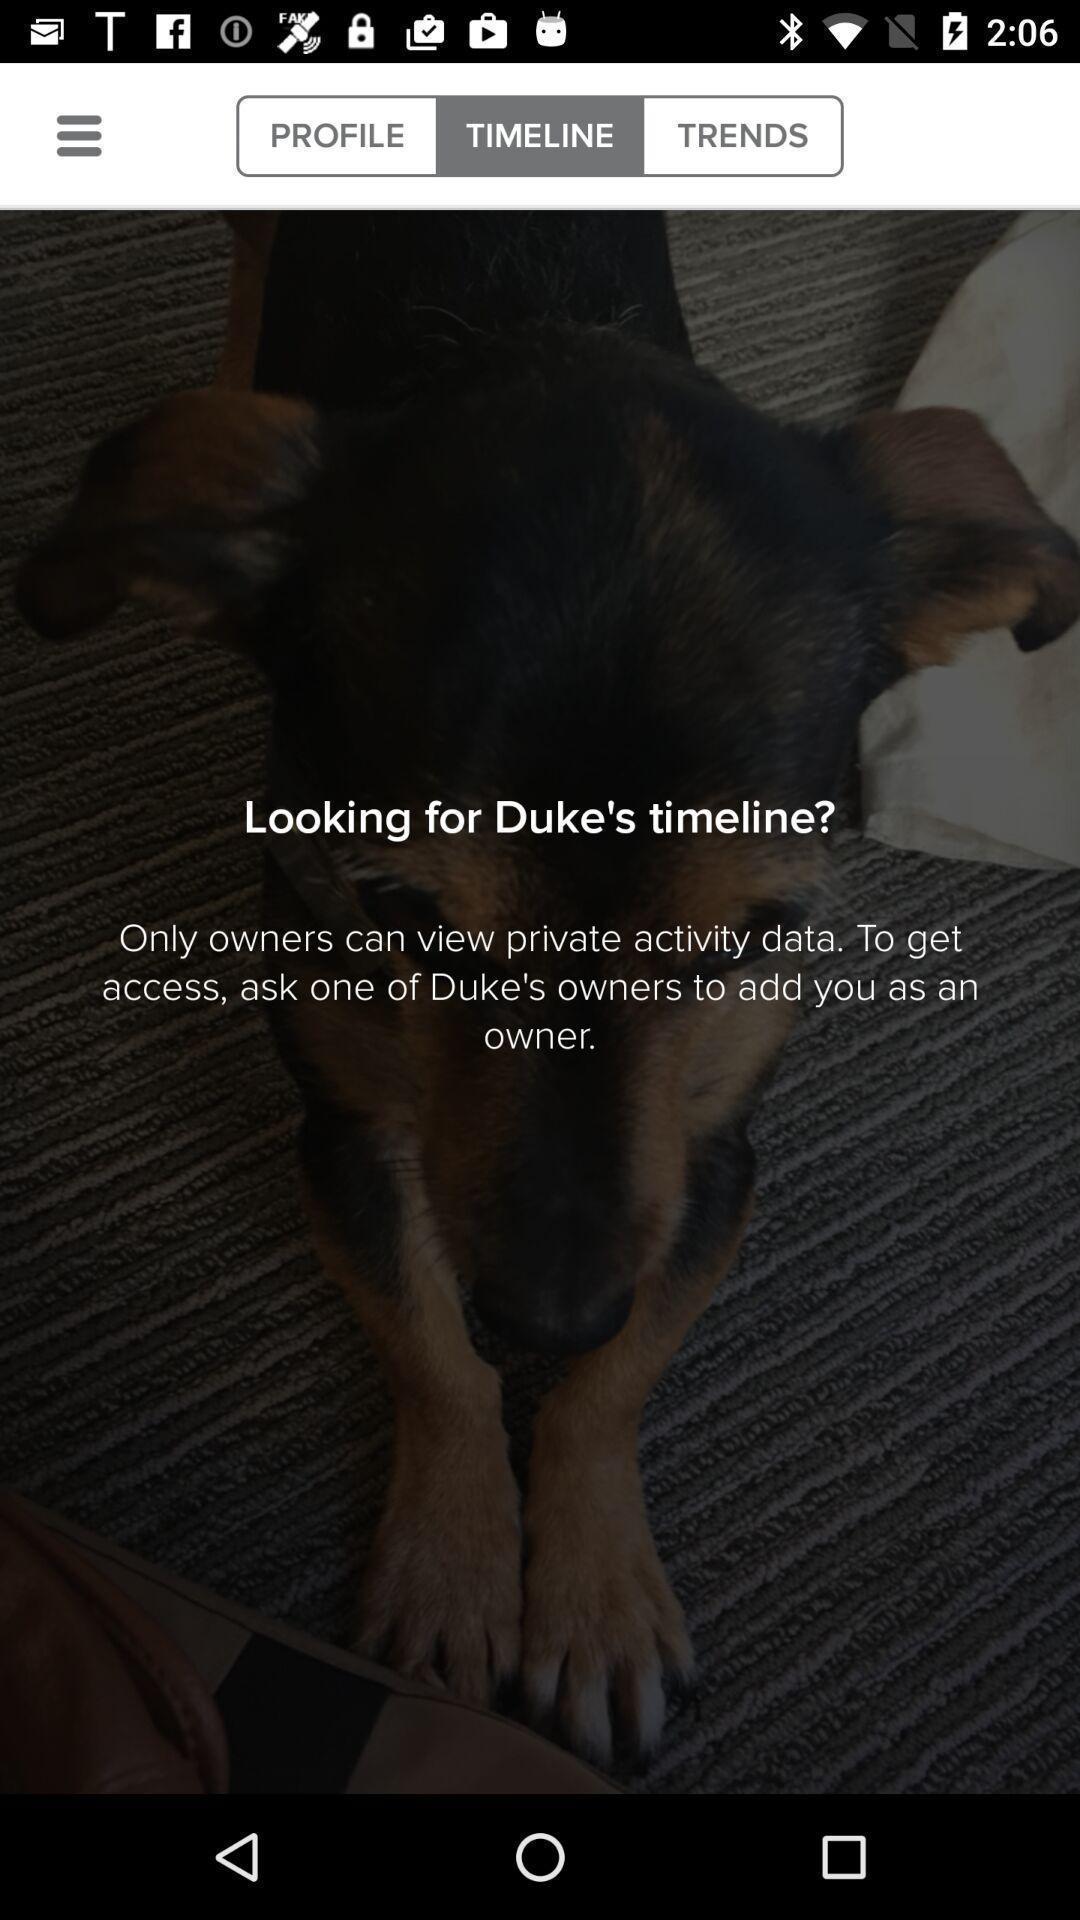Give me a narrative description of this picture. Screen shows timeline of an account. 